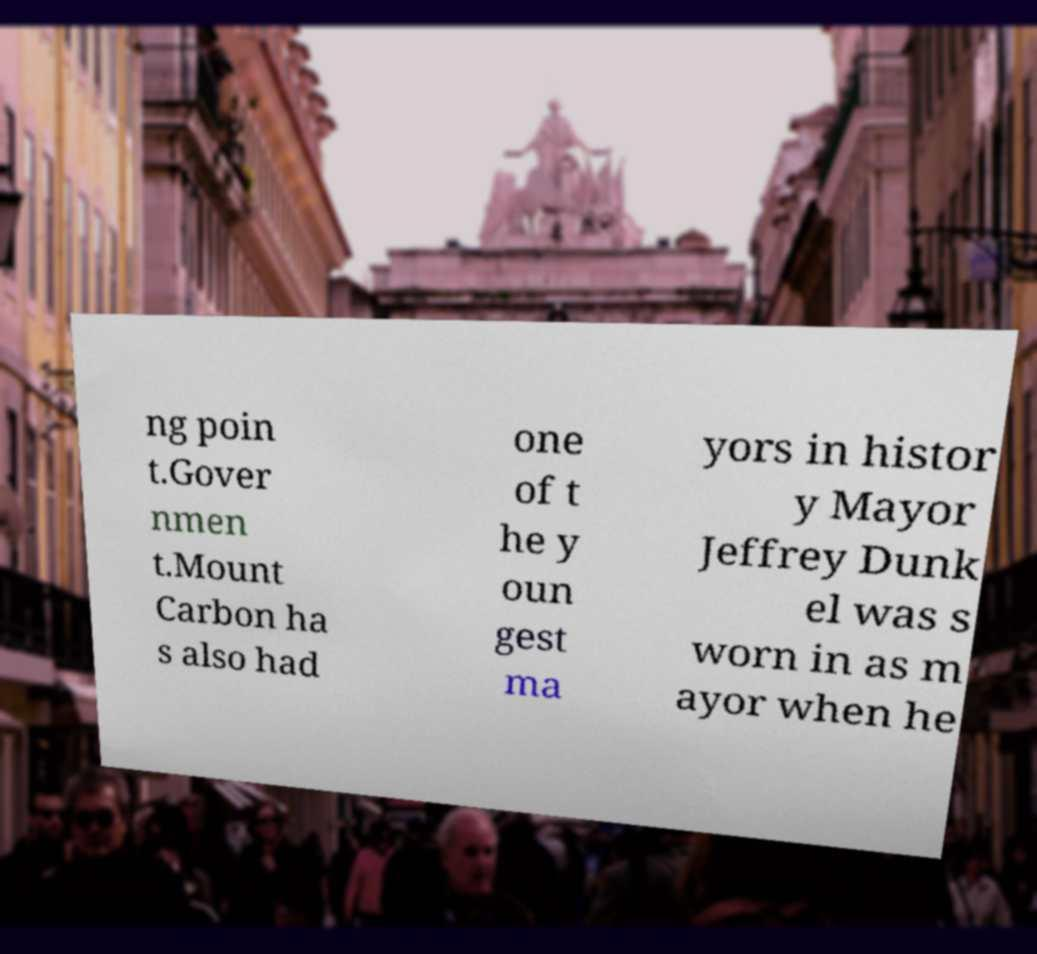Please read and relay the text visible in this image. What does it say? ng poin t.Gover nmen t.Mount Carbon ha s also had one of t he y oun gest ma yors in histor y Mayor Jeffrey Dunk el was s worn in as m ayor when he 